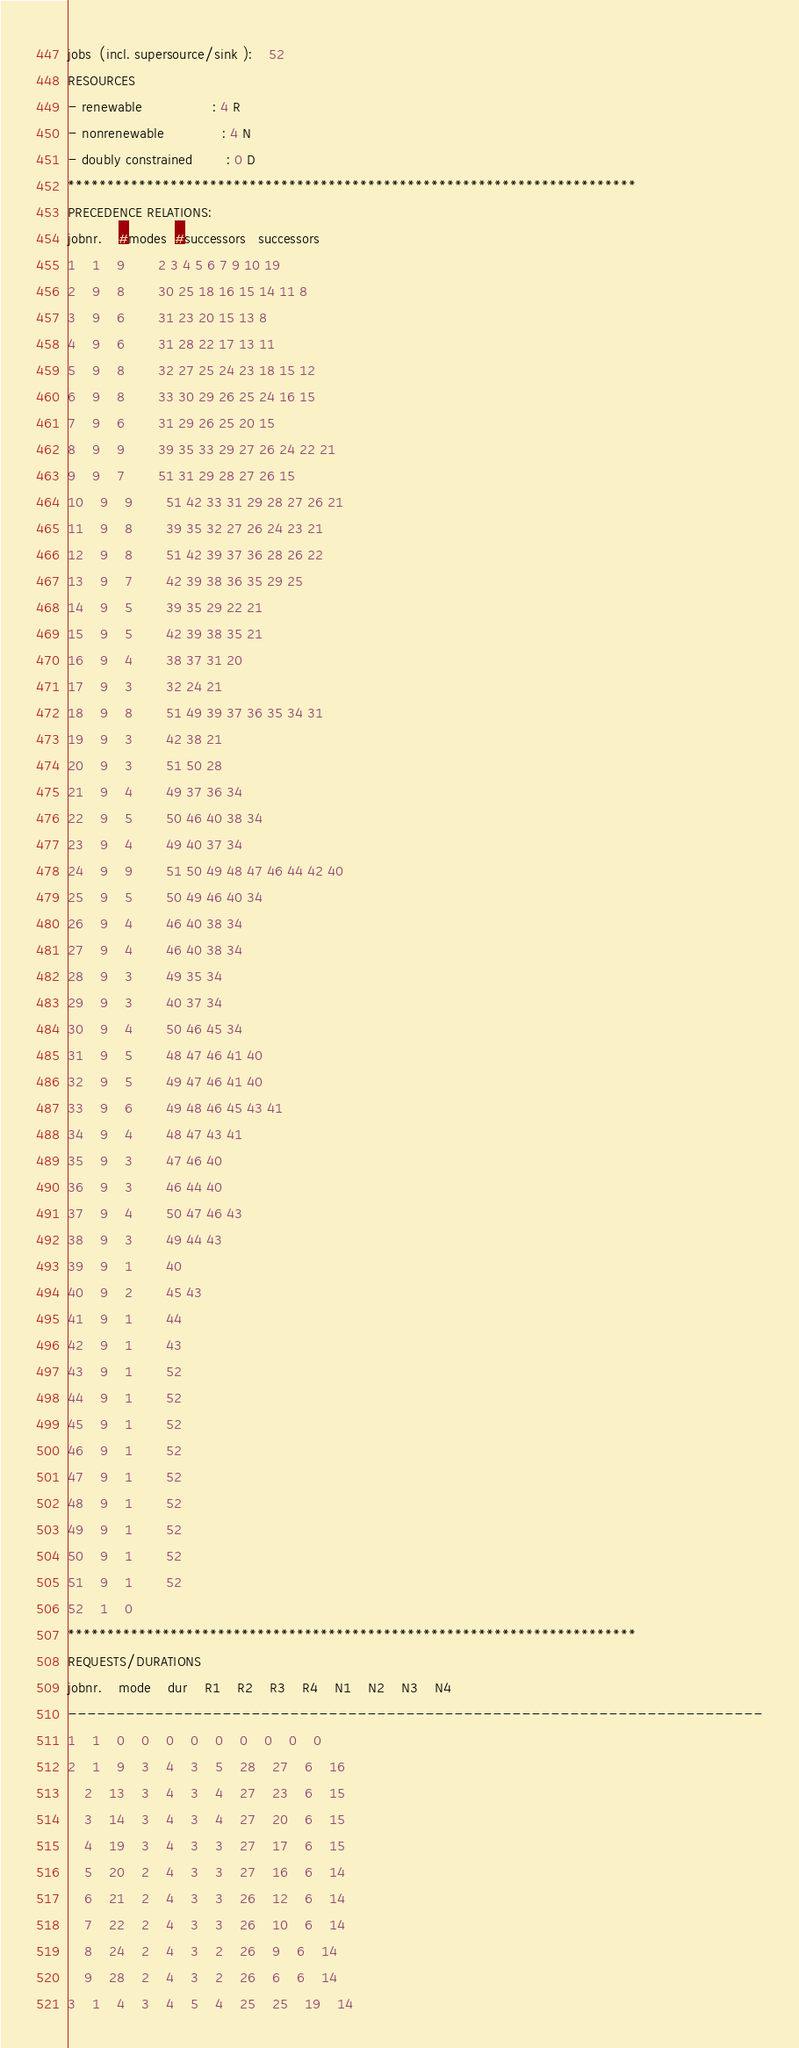Convert code to text. <code><loc_0><loc_0><loc_500><loc_500><_ObjectiveC_>jobs  (incl. supersource/sink ):	52
RESOURCES
- renewable                 : 4 R
- nonrenewable              : 4 N
- doubly constrained        : 0 D
************************************************************************
PRECEDENCE RELATIONS:
jobnr.    #modes  #successors   successors
1	1	9		2 3 4 5 6 7 9 10 19 
2	9	8		30 25 18 16 15 14 11 8 
3	9	6		31 23 20 15 13 8 
4	9	6		31 28 22 17 13 11 
5	9	8		32 27 25 24 23 18 15 12 
6	9	8		33 30 29 26 25 24 16 15 
7	9	6		31 29 26 25 20 15 
8	9	9		39 35 33 29 27 26 24 22 21 
9	9	7		51 31 29 28 27 26 15 
10	9	9		51 42 33 31 29 28 27 26 21 
11	9	8		39 35 32 27 26 24 23 21 
12	9	8		51 42 39 37 36 28 26 22 
13	9	7		42 39 38 36 35 29 25 
14	9	5		39 35 29 22 21 
15	9	5		42 39 38 35 21 
16	9	4		38 37 31 20 
17	9	3		32 24 21 
18	9	8		51 49 39 37 36 35 34 31 
19	9	3		42 38 21 
20	9	3		51 50 28 
21	9	4		49 37 36 34 
22	9	5		50 46 40 38 34 
23	9	4		49 40 37 34 
24	9	9		51 50 49 48 47 46 44 42 40 
25	9	5		50 49 46 40 34 
26	9	4		46 40 38 34 
27	9	4		46 40 38 34 
28	9	3		49 35 34 
29	9	3		40 37 34 
30	9	4		50 46 45 34 
31	9	5		48 47 46 41 40 
32	9	5		49 47 46 41 40 
33	9	6		49 48 46 45 43 41 
34	9	4		48 47 43 41 
35	9	3		47 46 40 
36	9	3		46 44 40 
37	9	4		50 47 46 43 
38	9	3		49 44 43 
39	9	1		40 
40	9	2		45 43 
41	9	1		44 
42	9	1		43 
43	9	1		52 
44	9	1		52 
45	9	1		52 
46	9	1		52 
47	9	1		52 
48	9	1		52 
49	9	1		52 
50	9	1		52 
51	9	1		52 
52	1	0		
************************************************************************
REQUESTS/DURATIONS
jobnr.	mode	dur	R1	R2	R3	R4	N1	N2	N3	N4	
------------------------------------------------------------------------
1	1	0	0	0	0	0	0	0	0	0	
2	1	9	3	4	3	5	28	27	6	16	
	2	13	3	4	3	4	27	23	6	15	
	3	14	3	4	3	4	27	20	6	15	
	4	19	3	4	3	3	27	17	6	15	
	5	20	2	4	3	3	27	16	6	14	
	6	21	2	4	3	3	26	12	6	14	
	7	22	2	4	3	3	26	10	6	14	
	8	24	2	4	3	2	26	9	6	14	
	9	28	2	4	3	2	26	6	6	14	
3	1	4	3	4	5	4	25	25	19	14	</code> 